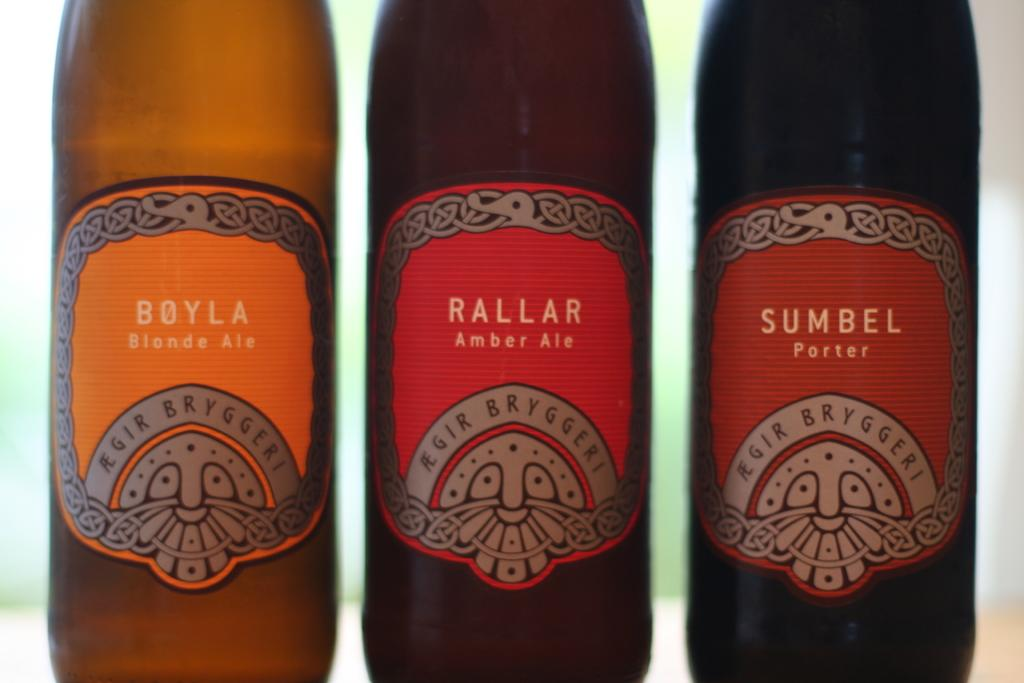<image>
Present a compact description of the photo's key features. Three different colored bottles of Boyla, Rallar, adn Sumbel. 